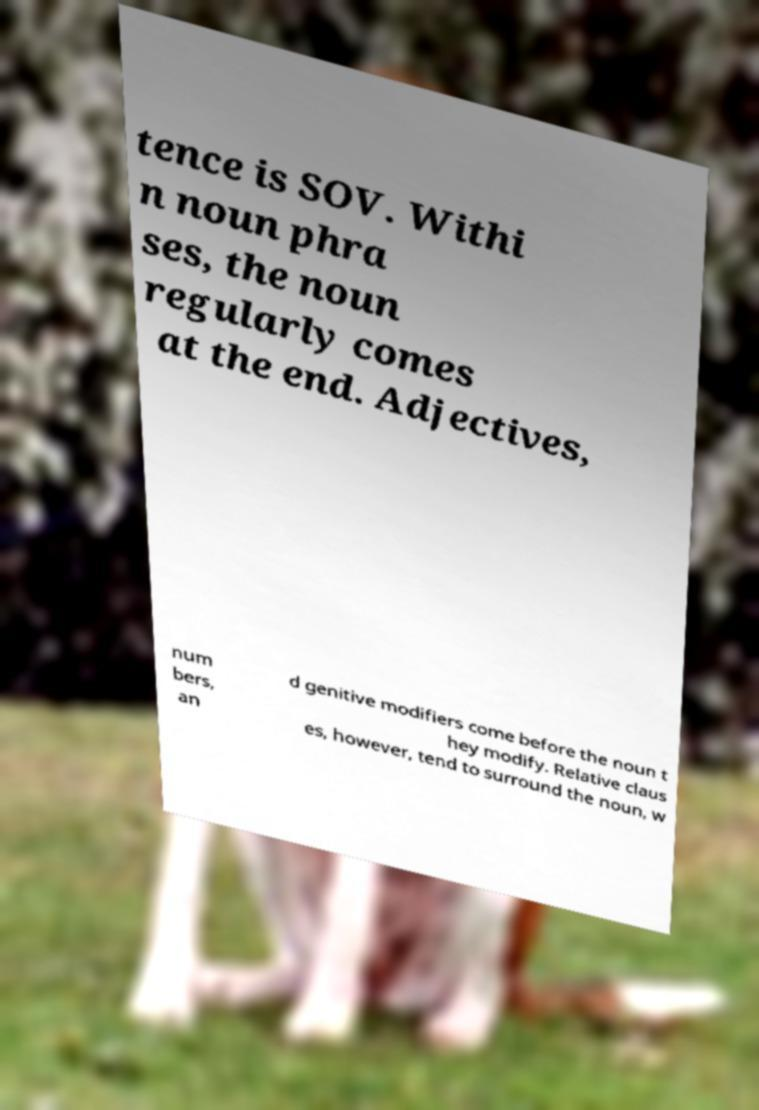Could you extract and type out the text from this image? tence is SOV. Withi n noun phra ses, the noun regularly comes at the end. Adjectives, num bers, an d genitive modifiers come before the noun t hey modify. Relative claus es, however, tend to surround the noun, w 